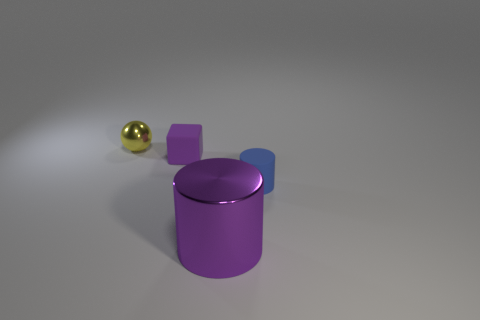Add 3 large brown matte spheres. How many objects exist? 7 Subtract all small red matte spheres. Subtract all blocks. How many objects are left? 3 Add 1 purple metallic things. How many purple metallic things are left? 2 Add 1 tiny matte cylinders. How many tiny matte cylinders exist? 2 Subtract 0 blue cubes. How many objects are left? 4 